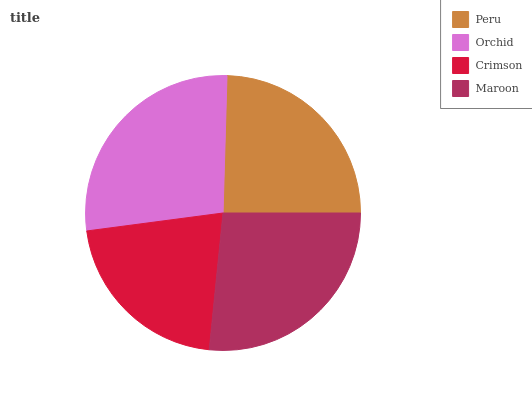Is Crimson the minimum?
Answer yes or no. Yes. Is Orchid the maximum?
Answer yes or no. Yes. Is Orchid the minimum?
Answer yes or no. No. Is Crimson the maximum?
Answer yes or no. No. Is Orchid greater than Crimson?
Answer yes or no. Yes. Is Crimson less than Orchid?
Answer yes or no. Yes. Is Crimson greater than Orchid?
Answer yes or no. No. Is Orchid less than Crimson?
Answer yes or no. No. Is Maroon the high median?
Answer yes or no. Yes. Is Peru the low median?
Answer yes or no. Yes. Is Peru the high median?
Answer yes or no. No. Is Crimson the low median?
Answer yes or no. No. 